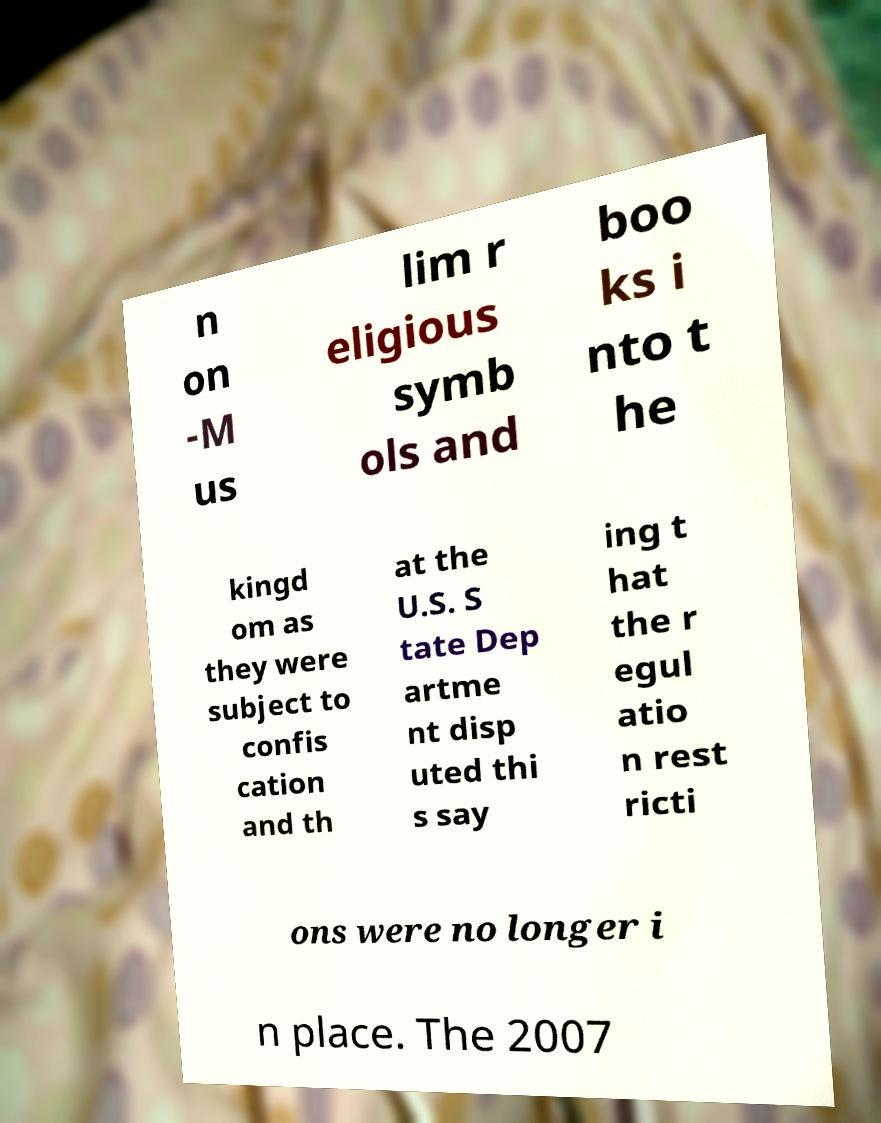Can you accurately transcribe the text from the provided image for me? n on -M us lim r eligious symb ols and boo ks i nto t he kingd om as they were subject to confis cation and th at the U.S. S tate Dep artme nt disp uted thi s say ing t hat the r egul atio n rest ricti ons were no longer i n place. The 2007 